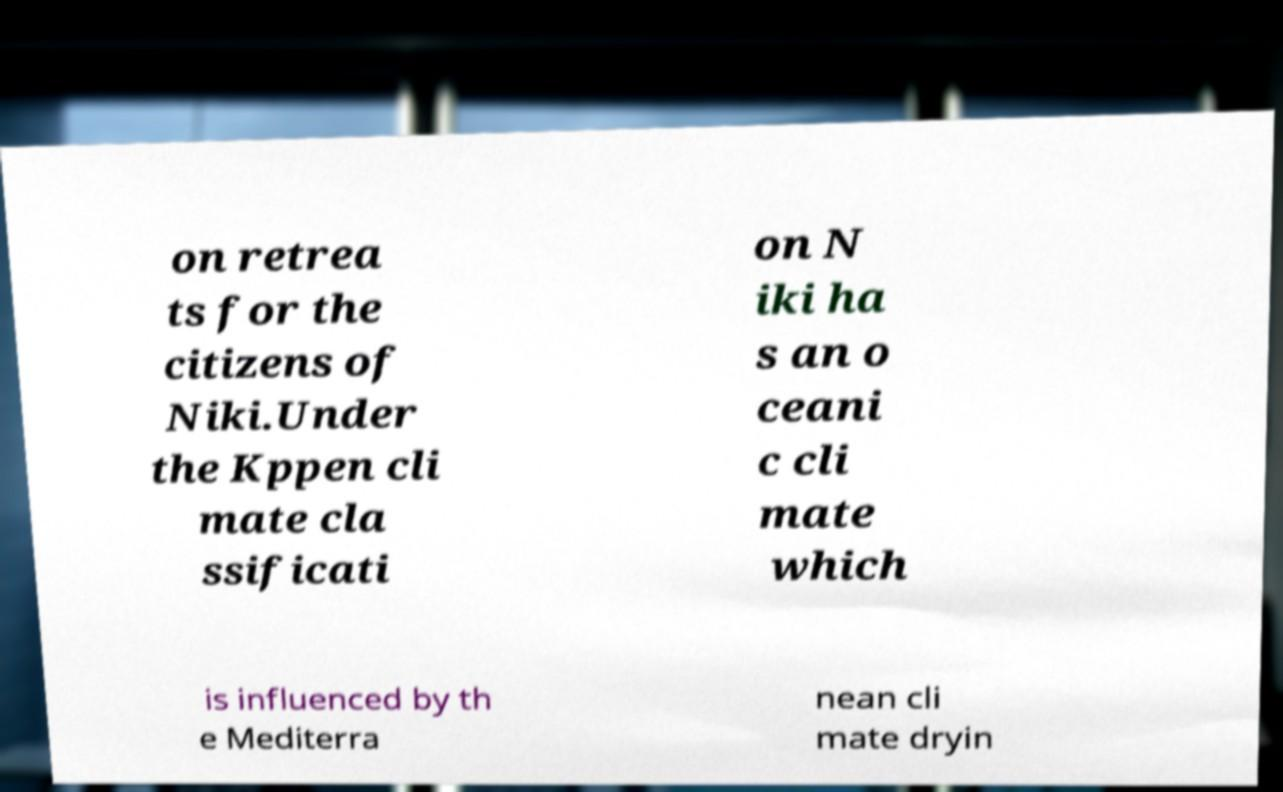I need the written content from this picture converted into text. Can you do that? on retrea ts for the citizens of Niki.Under the Kppen cli mate cla ssificati on N iki ha s an o ceani c cli mate which is influenced by th e Mediterra nean cli mate dryin 